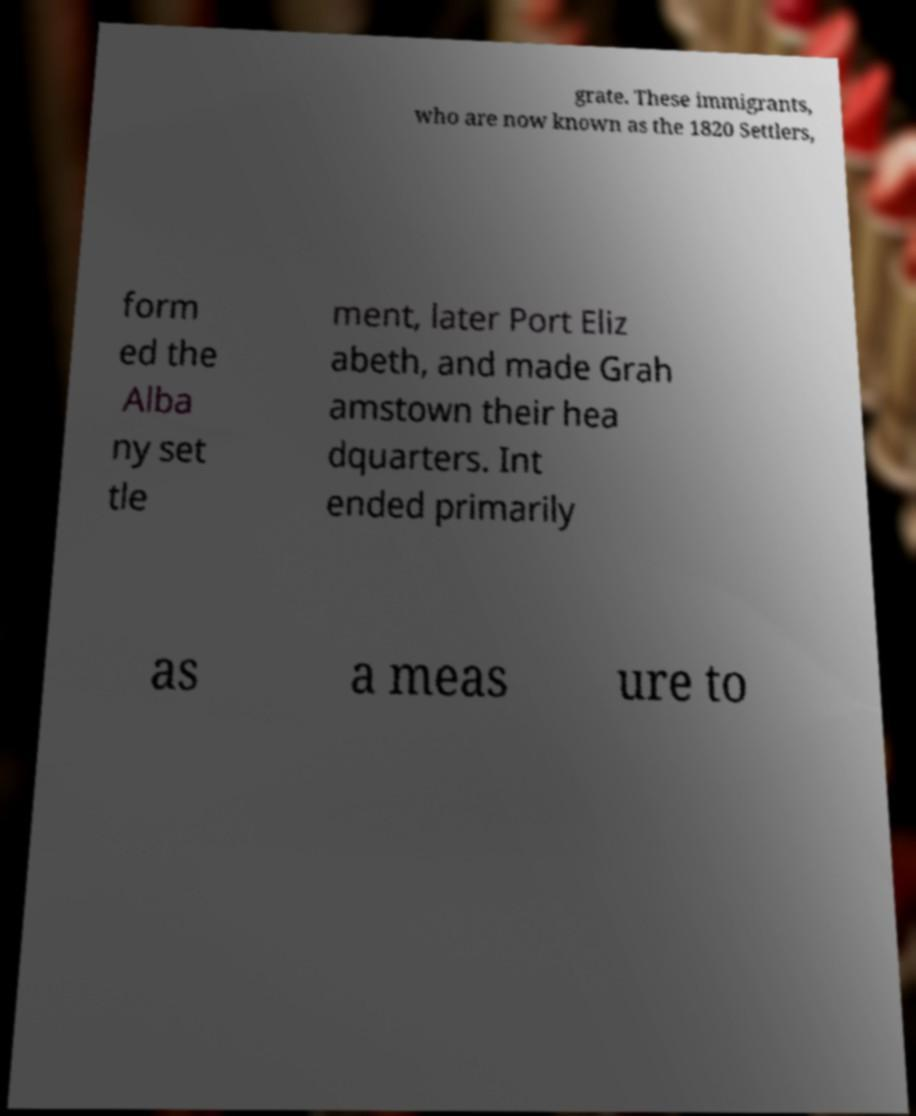Please identify and transcribe the text found in this image. grate. These immigrants, who are now known as the 1820 Settlers, form ed the Alba ny set tle ment, later Port Eliz abeth, and made Grah amstown their hea dquarters. Int ended primarily as a meas ure to 